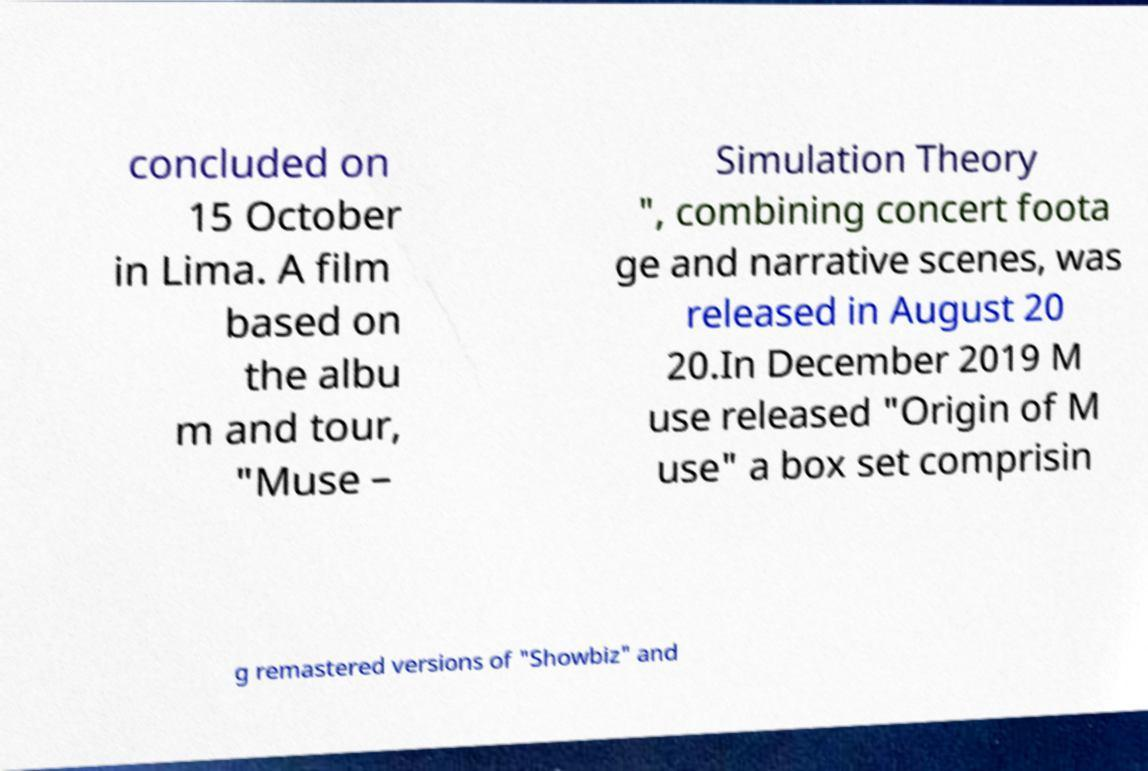Could you extract and type out the text from this image? concluded on 15 October in Lima. A film based on the albu m and tour, "Muse – Simulation Theory ", combining concert foota ge and narrative scenes, was released in August 20 20.In December 2019 M use released "Origin of M use" a box set comprisin g remastered versions of "Showbiz" and 